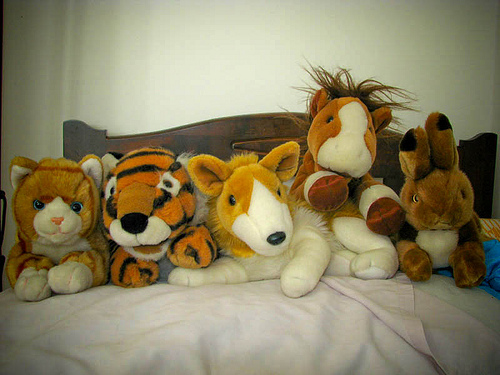<image>
Is the stuff animal to the right of the stuff cat? Yes. From this viewpoint, the stuff animal is positioned to the right side relative to the stuff cat. 